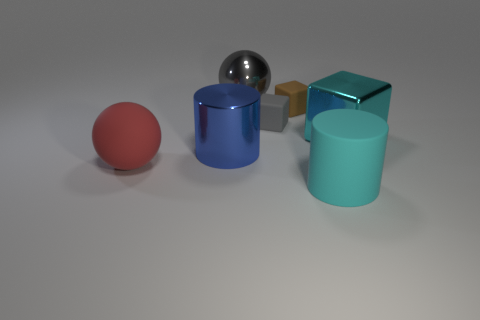Do the red rubber thing and the large rubber object that is in front of the red ball have the same shape? No, the shapes are different. The red object appears to be a sphere, whereas the large rubber object in front of the red ball is cylindrical. 